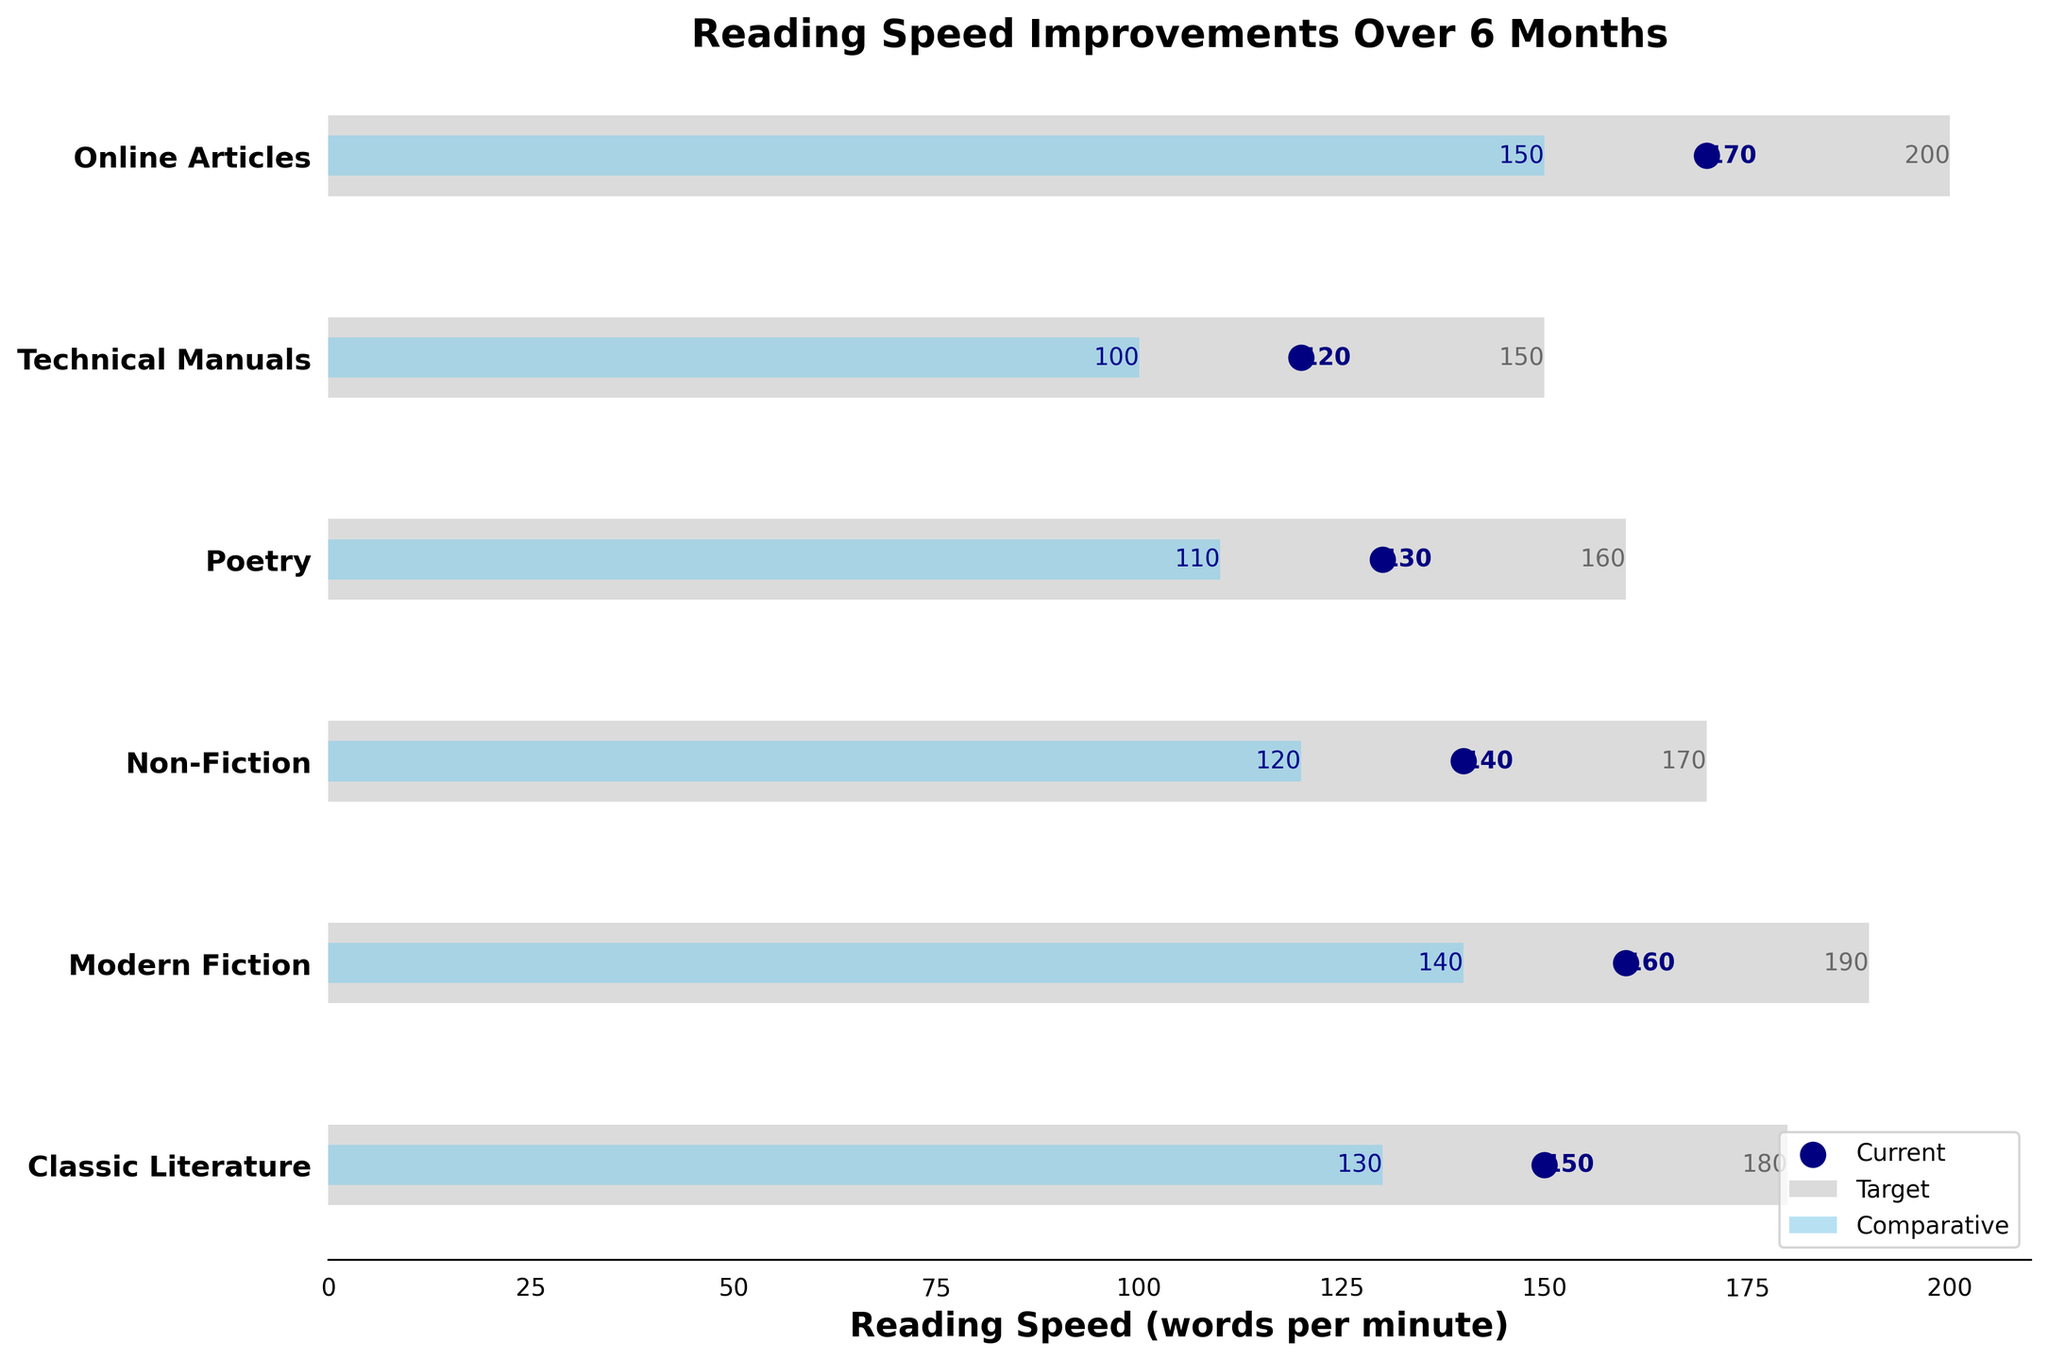What is the title of the figure? The title of the figure is displayed at the top center of the chart in larger, bold font.
Answer: Reading Speed Improvements Over 6 Months What color represents the current reading speed in the figure? The current reading speed is represented by navy scatter points.
Answer: Navy Which category has the highest current reading speed? To find this, look for the highest-positioned navy scatter point along the horizontal axis.
Answer: Online Articles How much higher is the target reading speed compared to the current speed for Classic Literature? The target speed for Classic Literature is 180 words per minute, and the current speed is 150 words per minute. The difference is 180 - 150.
Answer: 30 words per minute In which category is the current reading speed closer to the comparative speed? Compare the navy scatter points to the sky blue bars to see which are closest in each category.
Answer: Classic Literature What is the average target reading speed across all categories? To calculate the average target speed, sum all the target values and then divide by the number of categories. (180 + 190 + 170 + 160 + 150 + 200) / 6 = 1050 / 6.
Answer: 175 words per minute Which category has the smallest improvement needed to reach the target, based on current reading speed? Find the category with the smallest difference between the current speed (navy scatter points) and the target speed (light grey bars).
Answer: Online Articles What's the difference between the highest and lowest target reading speeds? The highest target reading speed is 200 (Online Articles), and the lowest is 150 (Technical Manuals). The difference is 200 - 150.
Answer: 50 words per minute In how many categories is the comparative reading speed at least 20 words per minute below the target? Compare each comparative speed (sky blue bars) to the corresponding target speed (light grey bars) and count how many are 20 or more words per minute lower.
Answer: 5 categories 